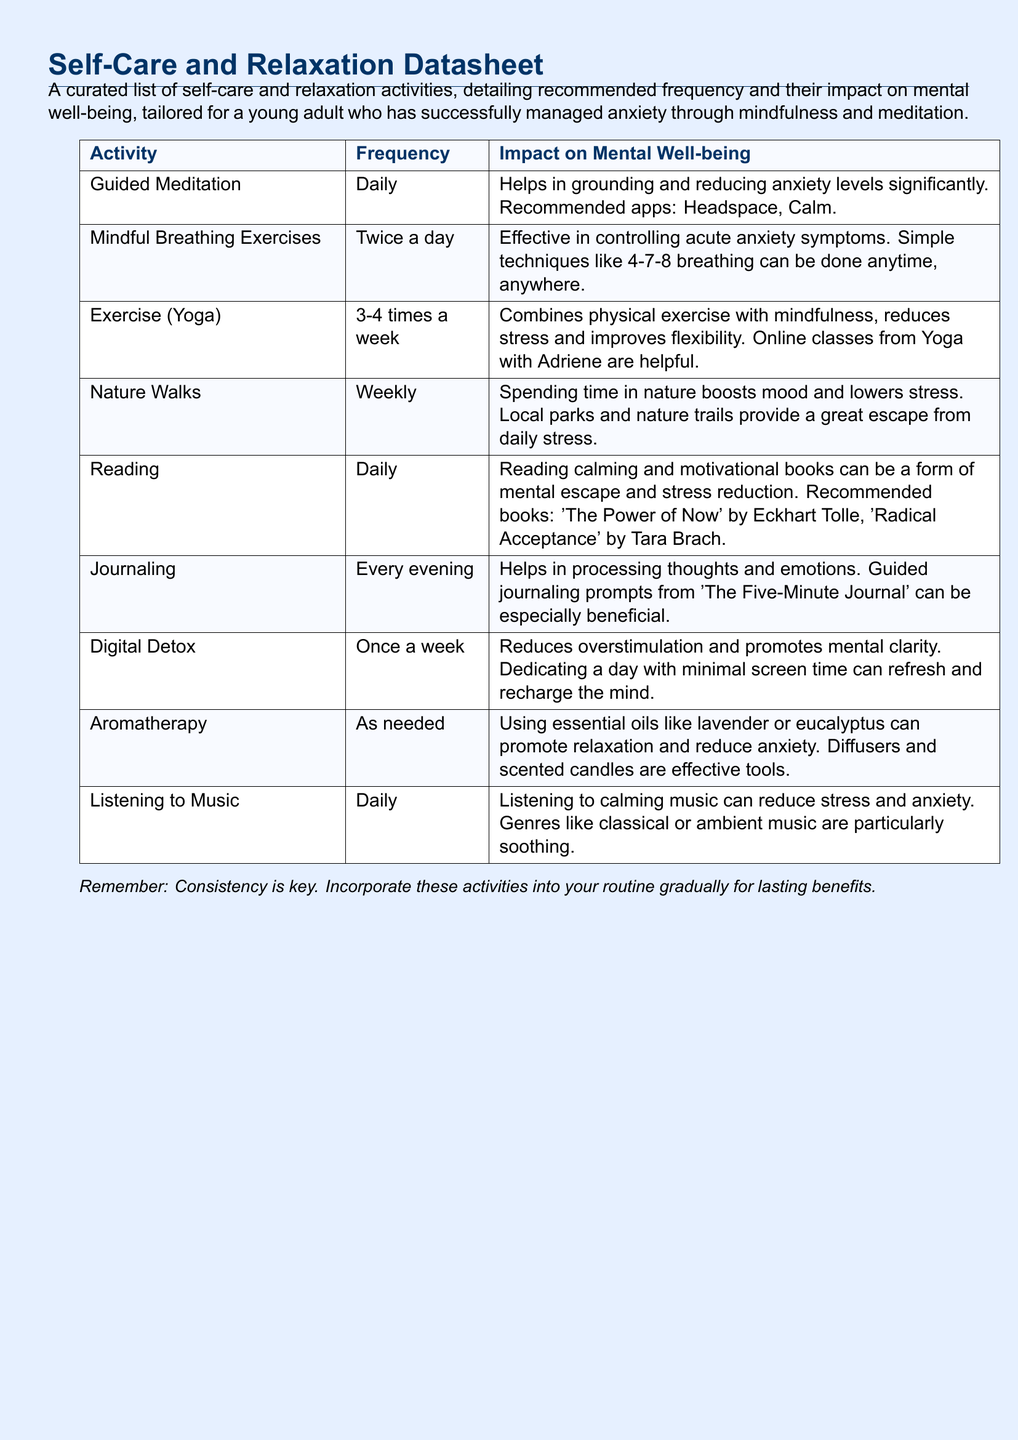What is the recommended frequency for guided meditation? The document specifies that guided meditation should be practiced daily.
Answer: Daily How often should one engage in mindful breathing exercises? The datasheet indicates that mindful breathing exercises should be done twice a day.
Answer: Twice a day What is the impact of nature walks on mental well-being? The document notes that spending time in nature boosts mood and lowers stress.
Answer: Boosts mood and lowers stress Which activity is suggested for stress reduction through reading? The document mentions calming and motivational books as a form of mental escape and stress reduction.
Answer: Calming and motivational books What essential oils are mentioned for aromatherapy? The datasheet lists lavender and eucalyptus as effective essential oils for relaxation.
Answer: Lavender and eucalyptus How many times a week is exercise (yoga) recommended? According to the document, exercise (yoga) is recommended 3-4 times a week.
Answer: 3-4 times a week What type of music is advised for reducing stress? The document suggests listening to calming music, specifically classical or ambient music.
Answer: Calming music When should digital detox be practiced? The datasheet states that a digital detox should be done once a week.
Answer: Once a week What is the role of journaling in mental well-being? The document explains that journaling helps in processing thoughts and emotions.
Answer: Processing thoughts and emotions 